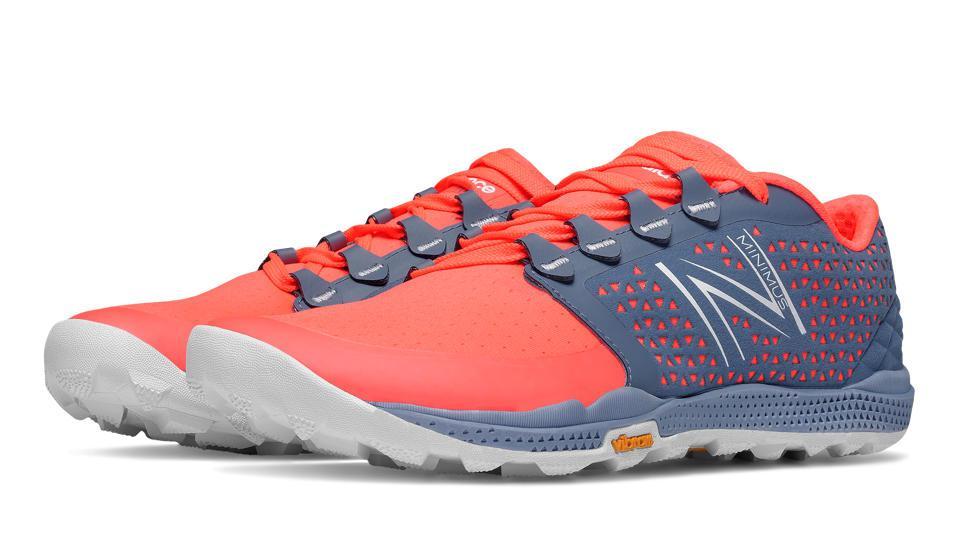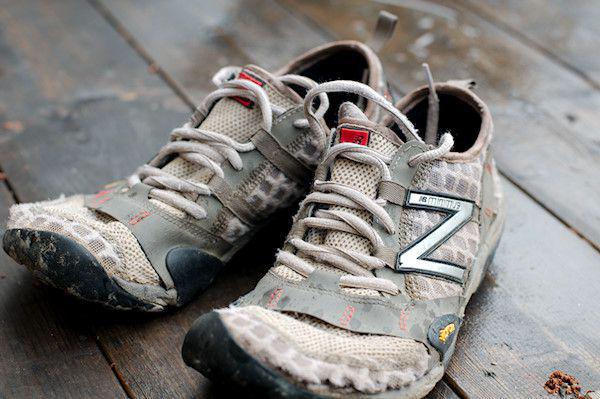The first image is the image on the left, the second image is the image on the right. Given the left and right images, does the statement "In total, two pairs of sneakers are shown." hold true? Answer yes or no. Yes. 